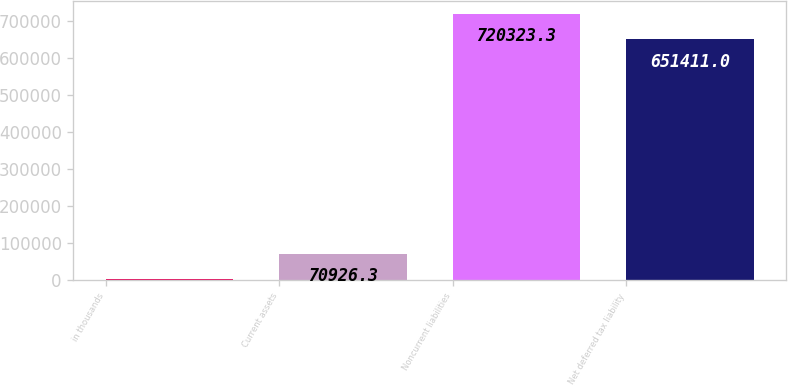<chart> <loc_0><loc_0><loc_500><loc_500><bar_chart><fcel>in thousands<fcel>Current assets<fcel>Noncurrent liabilities<fcel>Net deferred tax liability<nl><fcel>2014<fcel>70926.3<fcel>720323<fcel>651411<nl></chart> 